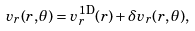Convert formula to latex. <formula><loc_0><loc_0><loc_500><loc_500>v _ { r } ( r , \theta ) = v _ { r } ^ { \text {1D} } ( r ) + \delta v _ { r } ( r , \theta ) ,</formula> 